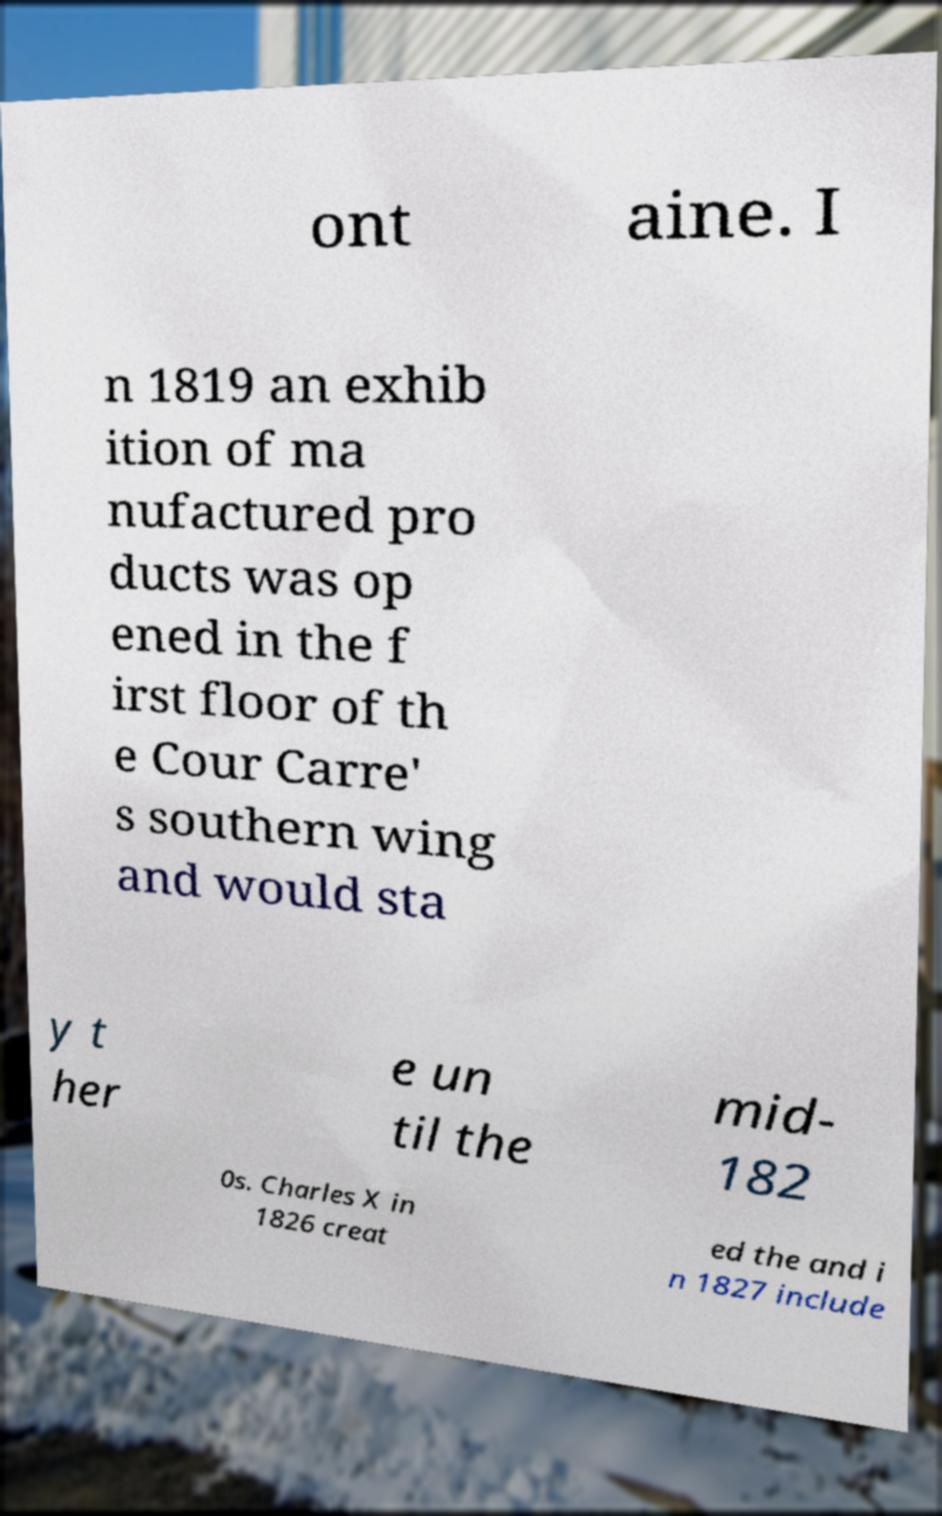Can you accurately transcribe the text from the provided image for me? ont aine. I n 1819 an exhib ition of ma nufactured pro ducts was op ened in the f irst floor of th e Cour Carre' s southern wing and would sta y t her e un til the mid- 182 0s. Charles X in 1826 creat ed the and i n 1827 include 